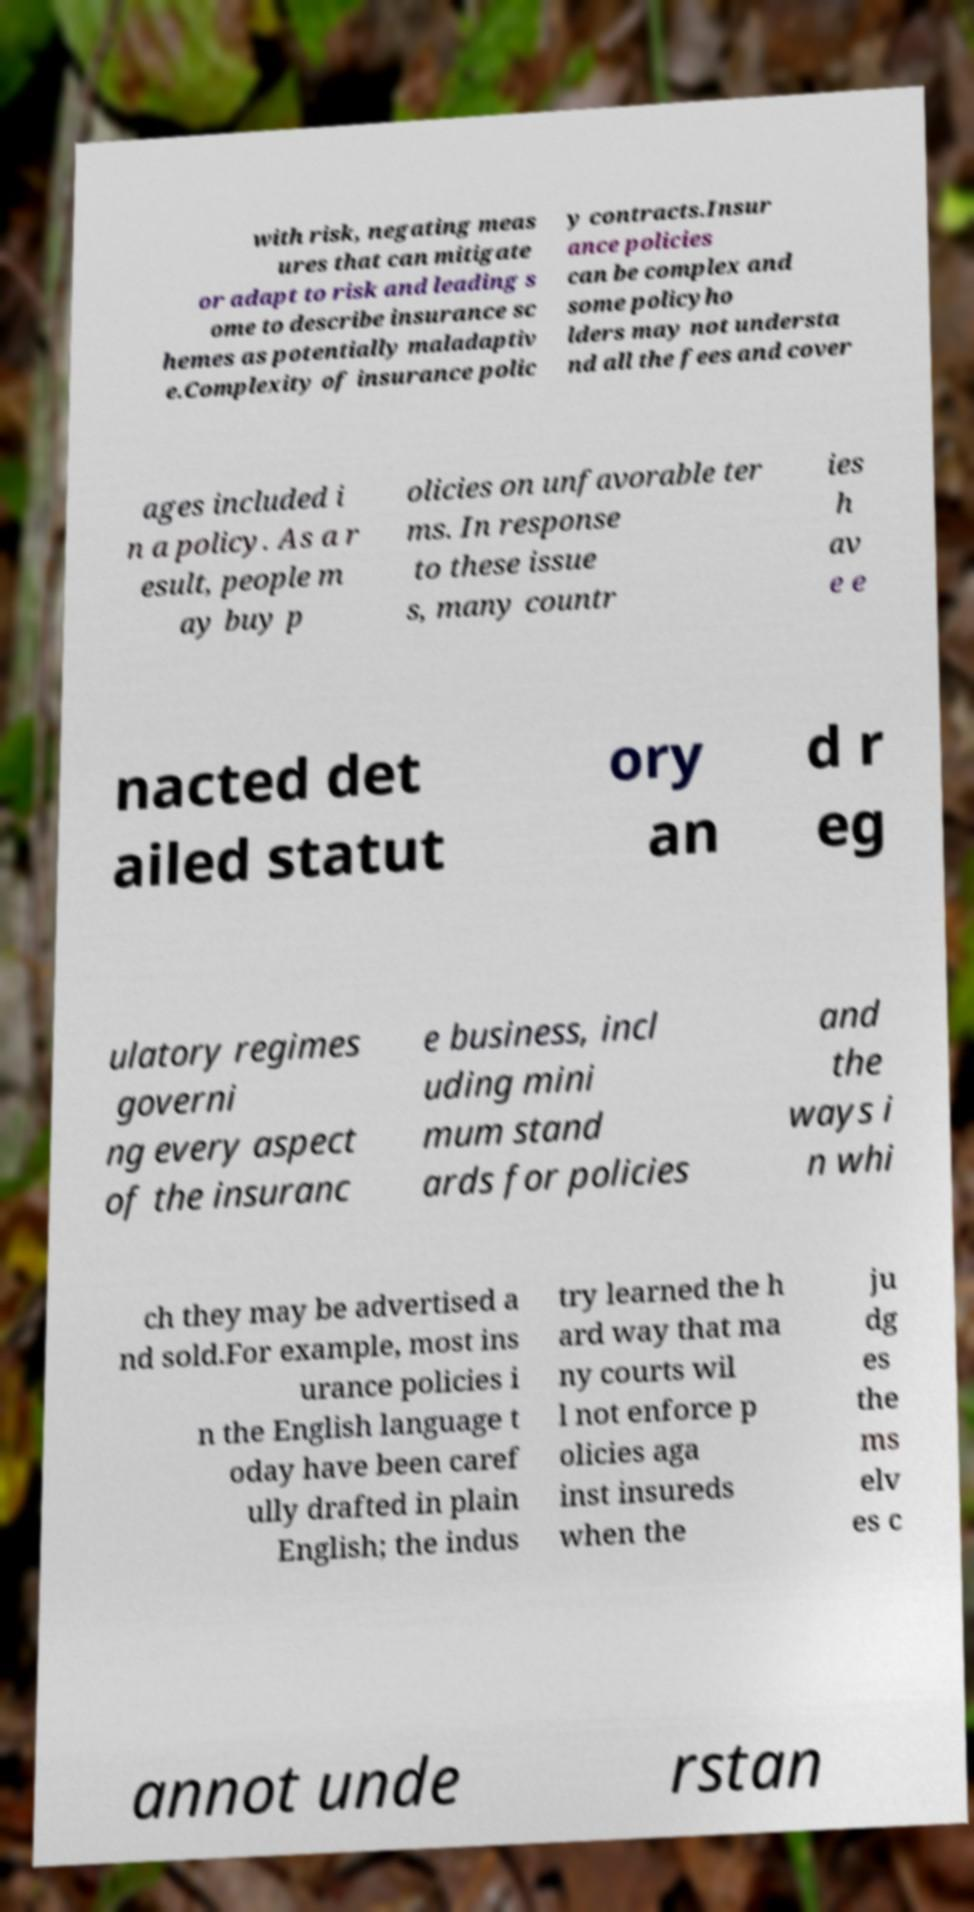Can you read and provide the text displayed in the image?This photo seems to have some interesting text. Can you extract and type it out for me? with risk, negating meas ures that can mitigate or adapt to risk and leading s ome to describe insurance sc hemes as potentially maladaptiv e.Complexity of insurance polic y contracts.Insur ance policies can be complex and some policyho lders may not understa nd all the fees and cover ages included i n a policy. As a r esult, people m ay buy p olicies on unfavorable ter ms. In response to these issue s, many countr ies h av e e nacted det ailed statut ory an d r eg ulatory regimes governi ng every aspect of the insuranc e business, incl uding mini mum stand ards for policies and the ways i n whi ch they may be advertised a nd sold.For example, most ins urance policies i n the English language t oday have been caref ully drafted in plain English; the indus try learned the h ard way that ma ny courts wil l not enforce p olicies aga inst insureds when the ju dg es the ms elv es c annot unde rstan 